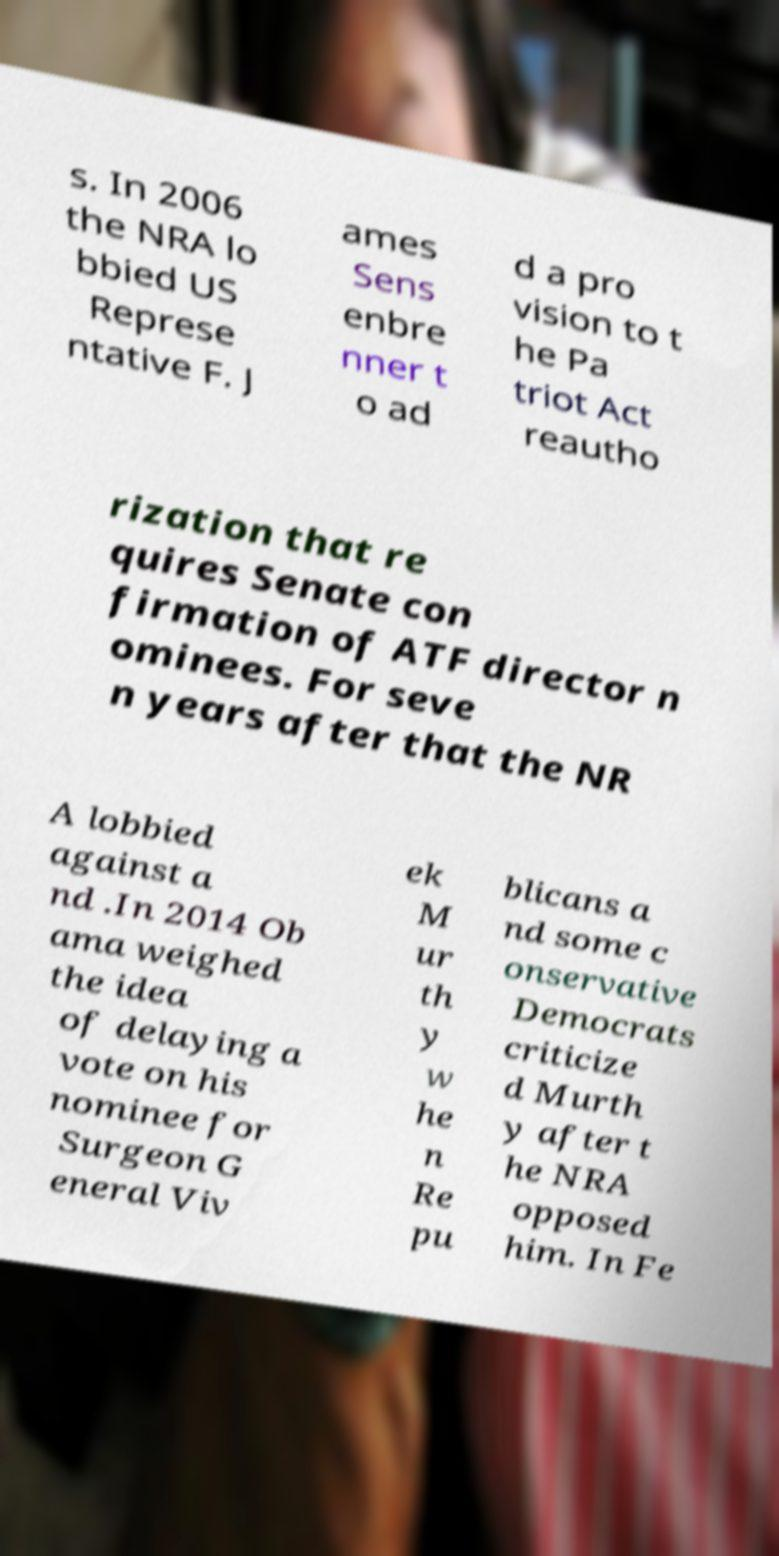There's text embedded in this image that I need extracted. Can you transcribe it verbatim? s. In 2006 the NRA lo bbied US Represe ntative F. J ames Sens enbre nner t o ad d a pro vision to t he Pa triot Act reautho rization that re quires Senate con firmation of ATF director n ominees. For seve n years after that the NR A lobbied against a nd .In 2014 Ob ama weighed the idea of delaying a vote on his nominee for Surgeon G eneral Viv ek M ur th y w he n Re pu blicans a nd some c onservative Democrats criticize d Murth y after t he NRA opposed him. In Fe 